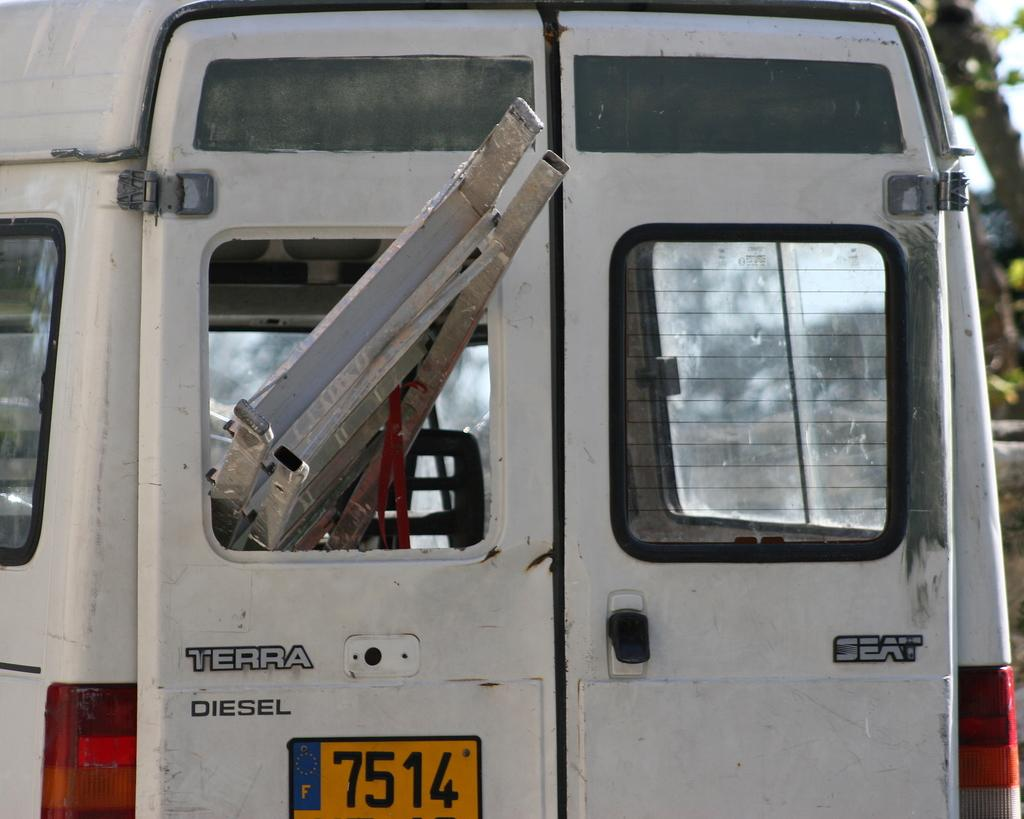What type of vehicle is in the picture? There is a white color van in the picture. How close is the view of the van in the image? The van is shown in a close view. What object can be seen inside the van through the window? There is a silver ladder visible in the window of the van. What type of aftermath can be seen in the field near the van? There is no aftermath or field present in the image; it only features a white color van with a silver ladder visible in the window. 